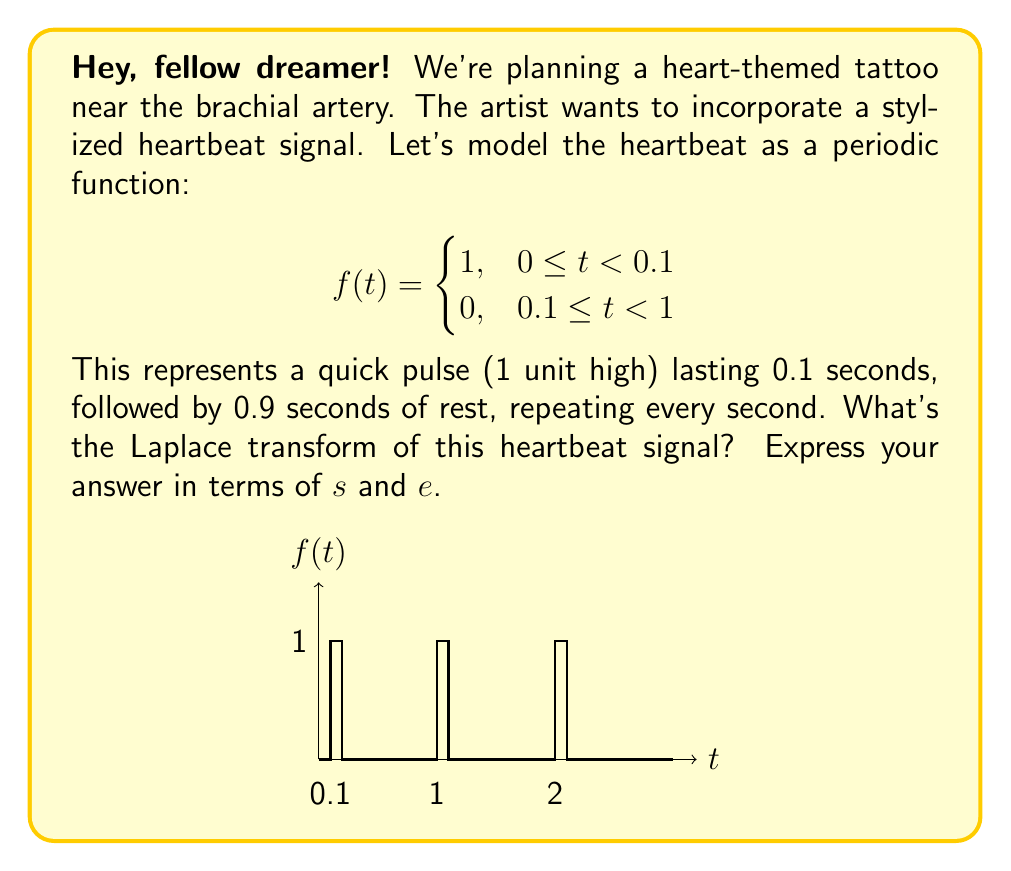Could you help me with this problem? Alright, let's break this down step-by-step, just like we used to plan our big dreams back in the day:

1) The Laplace transform of a periodic function with period $T$ is given by:

   $$F(s) = \frac{\int_0^T f(t)e^{-st}dt}{1-e^{-sT}}$$

2) In our case, $T = 1$ second. We need to calculate $\int_0^1 f(t)e^{-st}dt$:

   $$\int_0^1 f(t)e^{-st}dt = \int_0^{0.1} 1 \cdot e^{-st}dt + \int_{0.1}^1 0 \cdot e^{-st}dt$$

3) Simplify:

   $$\int_0^1 f(t)e^{-st}dt = \int_0^{0.1} e^{-st}dt$$

4) Solve the integral:

   $$\int_0^{0.1} e^{-st}dt = -\frac{1}{s}e^{-st}\bigg|_0^{0.1} = -\frac{1}{s}(e^{-0.1s} - 1)$$

5) Now, we can plug this into our Laplace transform formula:

   $$F(s) = \frac{-\frac{1}{s}(e^{-0.1s} - 1)}{1-e^{-s}}$$

6) Simplify:

   $$F(s) = \frac{1-e^{-0.1s}}{s(1-e^{-s})}$$

And there you have it! Just like how we turned our lives around, we've transformed that heartbeat into a mathematical expression.
Answer: $$F(s) = \frac{1-e^{-0.1s}}{s(1-e^{-s})}$$ 